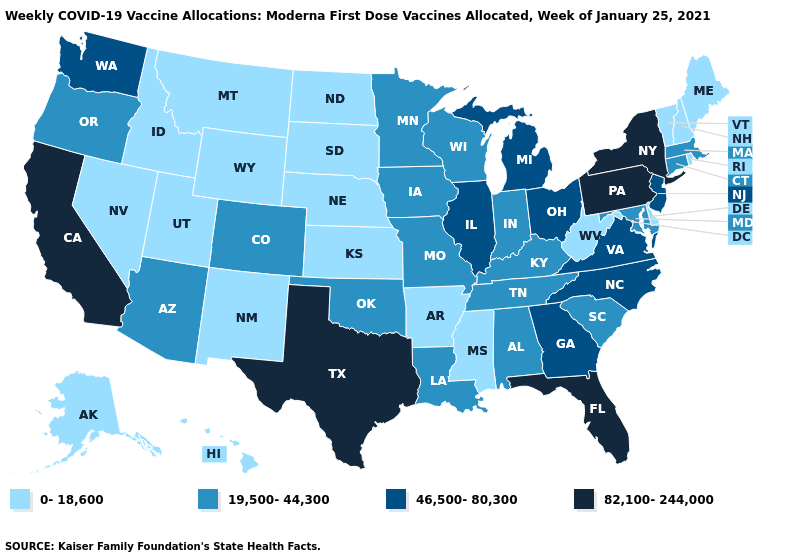Does the first symbol in the legend represent the smallest category?
Be succinct. Yes. Name the states that have a value in the range 82,100-244,000?
Short answer required. California, Florida, New York, Pennsylvania, Texas. Name the states that have a value in the range 0-18,600?
Give a very brief answer. Alaska, Arkansas, Delaware, Hawaii, Idaho, Kansas, Maine, Mississippi, Montana, Nebraska, Nevada, New Hampshire, New Mexico, North Dakota, Rhode Island, South Dakota, Utah, Vermont, West Virginia, Wyoming. Name the states that have a value in the range 82,100-244,000?
Write a very short answer. California, Florida, New York, Pennsylvania, Texas. What is the lowest value in the MidWest?
Short answer required. 0-18,600. Among the states that border Idaho , does Oregon have the lowest value?
Write a very short answer. No. How many symbols are there in the legend?
Be succinct. 4. Name the states that have a value in the range 82,100-244,000?
Short answer required. California, Florida, New York, Pennsylvania, Texas. Which states have the lowest value in the West?
Short answer required. Alaska, Hawaii, Idaho, Montana, Nevada, New Mexico, Utah, Wyoming. What is the highest value in the USA?
Write a very short answer. 82,100-244,000. Among the states that border Delaware , which have the lowest value?
Quick response, please. Maryland. Name the states that have a value in the range 0-18,600?
Short answer required. Alaska, Arkansas, Delaware, Hawaii, Idaho, Kansas, Maine, Mississippi, Montana, Nebraska, Nevada, New Hampshire, New Mexico, North Dakota, Rhode Island, South Dakota, Utah, Vermont, West Virginia, Wyoming. Among the states that border Mississippi , does Louisiana have the lowest value?
Keep it brief. No. Which states have the lowest value in the Northeast?
Concise answer only. Maine, New Hampshire, Rhode Island, Vermont. 